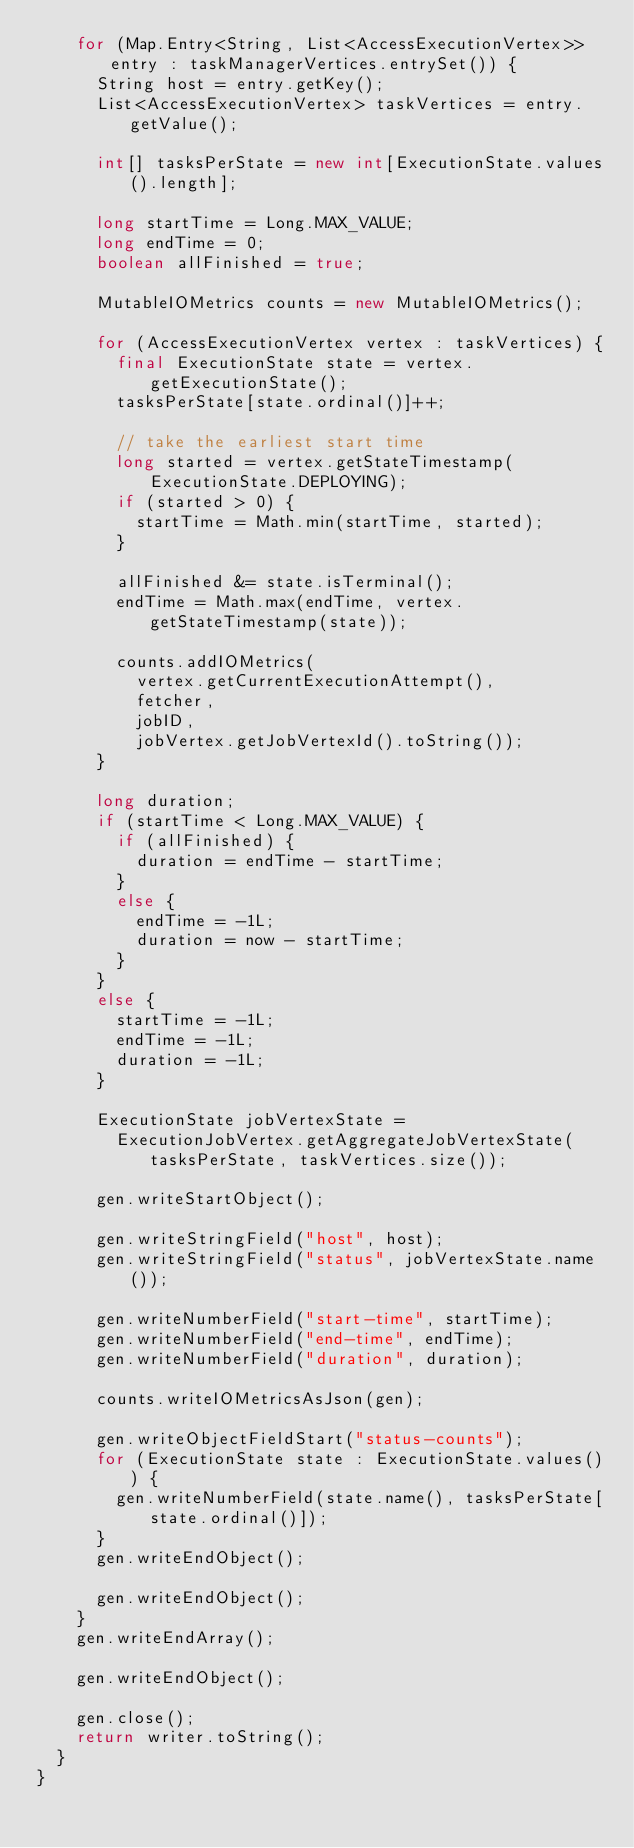Convert code to text. <code><loc_0><loc_0><loc_500><loc_500><_Java_>		for (Map.Entry<String, List<AccessExecutionVertex>> entry : taskManagerVertices.entrySet()) {
			String host = entry.getKey();
			List<AccessExecutionVertex> taskVertices = entry.getValue();

			int[] tasksPerState = new int[ExecutionState.values().length];

			long startTime = Long.MAX_VALUE;
			long endTime = 0;
			boolean allFinished = true;

			MutableIOMetrics counts = new MutableIOMetrics();

			for (AccessExecutionVertex vertex : taskVertices) {
				final ExecutionState state = vertex.getExecutionState();
				tasksPerState[state.ordinal()]++;

				// take the earliest start time
				long started = vertex.getStateTimestamp(ExecutionState.DEPLOYING);
				if (started > 0) {
					startTime = Math.min(startTime, started);
				}

				allFinished &= state.isTerminal();
				endTime = Math.max(endTime, vertex.getStateTimestamp(state));

				counts.addIOMetrics(
					vertex.getCurrentExecutionAttempt(),
					fetcher,
					jobID,
					jobVertex.getJobVertexId().toString());
			}

			long duration;
			if (startTime < Long.MAX_VALUE) {
				if (allFinished) {
					duration = endTime - startTime;
				}
				else {
					endTime = -1L;
					duration = now - startTime;
				}
			}
			else {
				startTime = -1L;
				endTime = -1L;
				duration = -1L;
			}

			ExecutionState jobVertexState =
				ExecutionJobVertex.getAggregateJobVertexState(tasksPerState, taskVertices.size());

			gen.writeStartObject();

			gen.writeStringField("host", host);
			gen.writeStringField("status", jobVertexState.name());

			gen.writeNumberField("start-time", startTime);
			gen.writeNumberField("end-time", endTime);
			gen.writeNumberField("duration", duration);

			counts.writeIOMetricsAsJson(gen);

			gen.writeObjectFieldStart("status-counts");
			for (ExecutionState state : ExecutionState.values()) {
				gen.writeNumberField(state.name(), tasksPerState[state.ordinal()]);
			}
			gen.writeEndObject();

			gen.writeEndObject();
		}
		gen.writeEndArray();

		gen.writeEndObject();

		gen.close();
		return writer.toString();
	}
}
</code> 